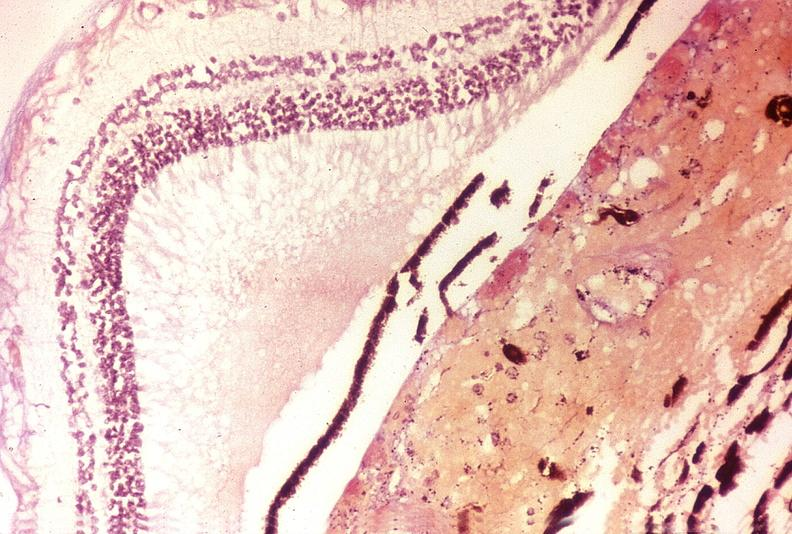does this image show disseminated intravascular coagulation dic?
Answer the question using a single word or phrase. Yes 